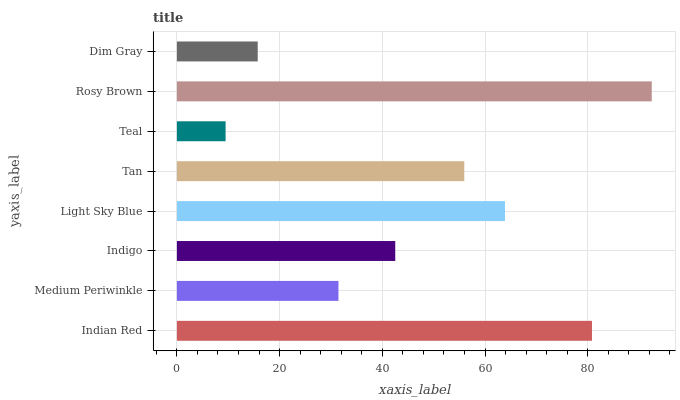Is Teal the minimum?
Answer yes or no. Yes. Is Rosy Brown the maximum?
Answer yes or no. Yes. Is Medium Periwinkle the minimum?
Answer yes or no. No. Is Medium Periwinkle the maximum?
Answer yes or no. No. Is Indian Red greater than Medium Periwinkle?
Answer yes or no. Yes. Is Medium Periwinkle less than Indian Red?
Answer yes or no. Yes. Is Medium Periwinkle greater than Indian Red?
Answer yes or no. No. Is Indian Red less than Medium Periwinkle?
Answer yes or no. No. Is Tan the high median?
Answer yes or no. Yes. Is Indigo the low median?
Answer yes or no. Yes. Is Rosy Brown the high median?
Answer yes or no. No. Is Medium Periwinkle the low median?
Answer yes or no. No. 